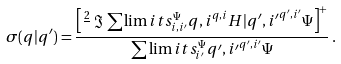Convert formula to latex. <formula><loc_0><loc_0><loc_500><loc_500>\sigma ( q | q ^ { \prime } ) = \frac { \left [ \frac { 2 } { } \, \Im \, \sum \lim i t s _ { i , i ^ { \prime } } ^ { \Psi } { q , i } ^ { q , i } { H | q ^ { \prime } , i ^ { \prime } } ^ { q ^ { \prime } , i ^ { \prime } } { \Psi } \right ] ^ { + } } { \sum \lim i t s _ { i ^ { \prime } } ^ { \Psi } { q ^ { \prime } , i ^ { \prime } } ^ { q ^ { \prime } , i ^ { \prime } } { \Psi } } \, .</formula> 